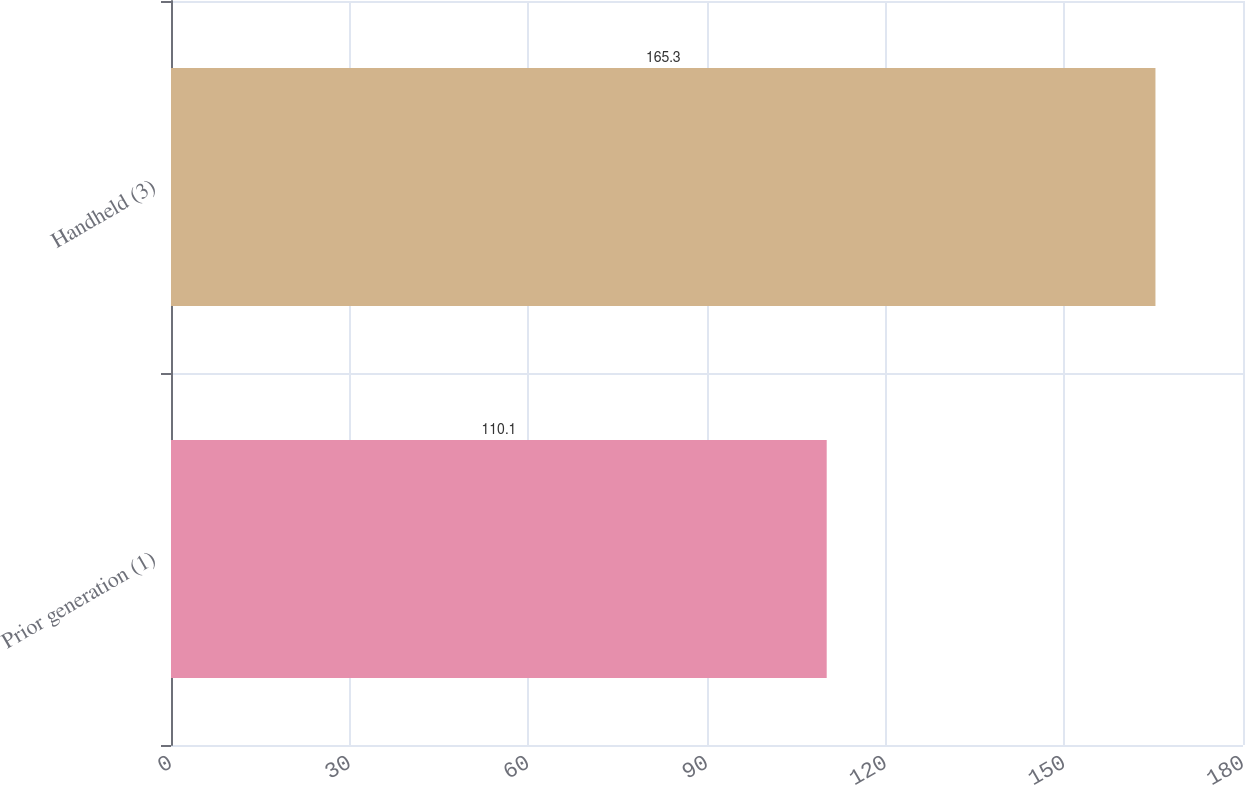Convert chart. <chart><loc_0><loc_0><loc_500><loc_500><bar_chart><fcel>Prior generation (1)<fcel>Handheld (3)<nl><fcel>110.1<fcel>165.3<nl></chart> 